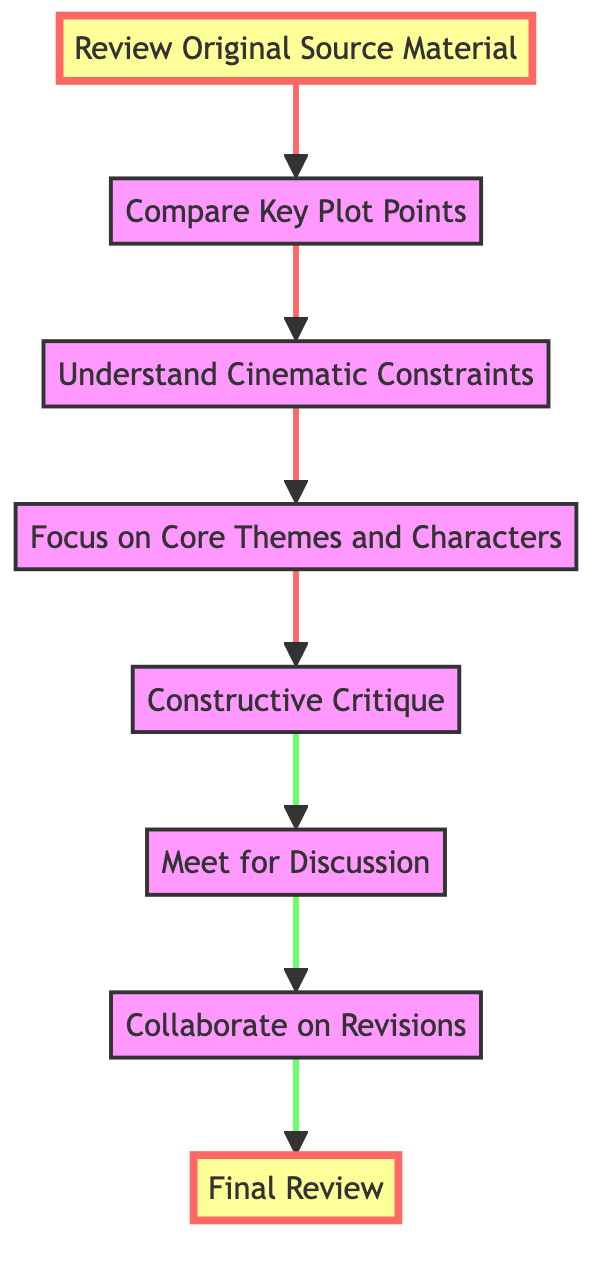What is the first step in the flow chart? The first step is labeled "Review Original Source Material," located at the top of the flowchart. It is connected to the next step, "Compare Key Plot Points," showing the progression of feedback strategies.
Answer: Review Original Source Material How many total steps are there in the diagram? The diagram includes a total of eight steps, representing the entire process from review to final review. This can be counted by identifying each labeled node in the flowchart.
Answer: Eight What is the last step before the "Final Review"? The last step before the "Final Review" is labeled "Collaborate on Revisions." It is the sixth step in the sequence, leading directly to the final review step.
Answer: Collaborate on Revisions What is the purpose of the "Understand Cinematic Constraints" step? This step emphasizes acknowledging the practical limitations of film, such as time constraints and the need for visual storytelling, which are crucial for constructing effective adaptations.
Answer: Acknowledge practical limitations Which steps focus on communication and collaboration? The steps "Meet for Discussion" and "Collaborate on Revisions" focus on communication and collaboration between the book author and the screenwriter or director. This collaboration ensures that feedback is properly integrated into the screenplay.
Answer: Meet for Discussion, Collaborate on Revisions What is the significance of the highlighted nodes in the diagram? The highlighted nodes, "Review Original Source Material" and "Final Review," signify critical points in the process that frame the feedback cycle: beginning with a strong understanding of the source and ending with a thorough review of changes.
Answer: Critical points in the process 